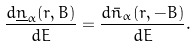<formula> <loc_0><loc_0><loc_500><loc_500>\frac { d \underline { n } _ { \alpha } ( { r } , B ) } { d E } = \frac { d \bar { n } _ { \alpha } ( { r } , - B ) } { d E } .</formula> 